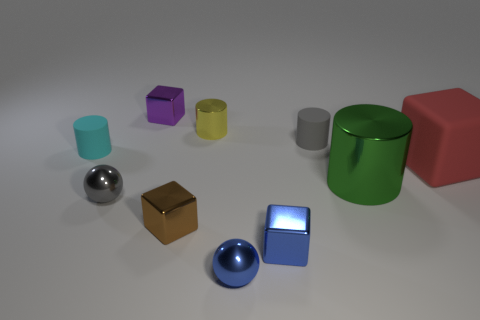How many objects in the image exhibit reflective surfaces? There are two distinctly reflective surfaces: the two metal balls. Other objects have matte finishes that reflect light less intensely. 